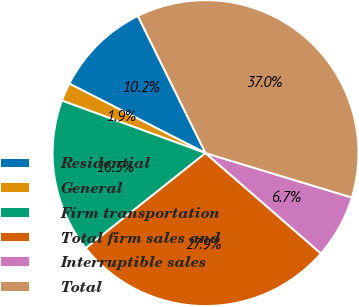Convert chart to OTSL. <chart><loc_0><loc_0><loc_500><loc_500><pie_chart><fcel>Residential<fcel>General<fcel>Firm transportation<fcel>Total firm sales and<fcel>Interruptible sales<fcel>Total<nl><fcel>10.2%<fcel>1.93%<fcel>16.26%<fcel>27.93%<fcel>6.7%<fcel>36.99%<nl></chart> 